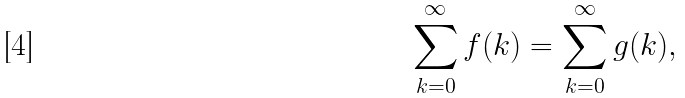<formula> <loc_0><loc_0><loc_500><loc_500>\sum _ { k = 0 } ^ { \infty } f ( k ) = \sum _ { k = 0 } ^ { \infty } g ( k ) ,</formula> 